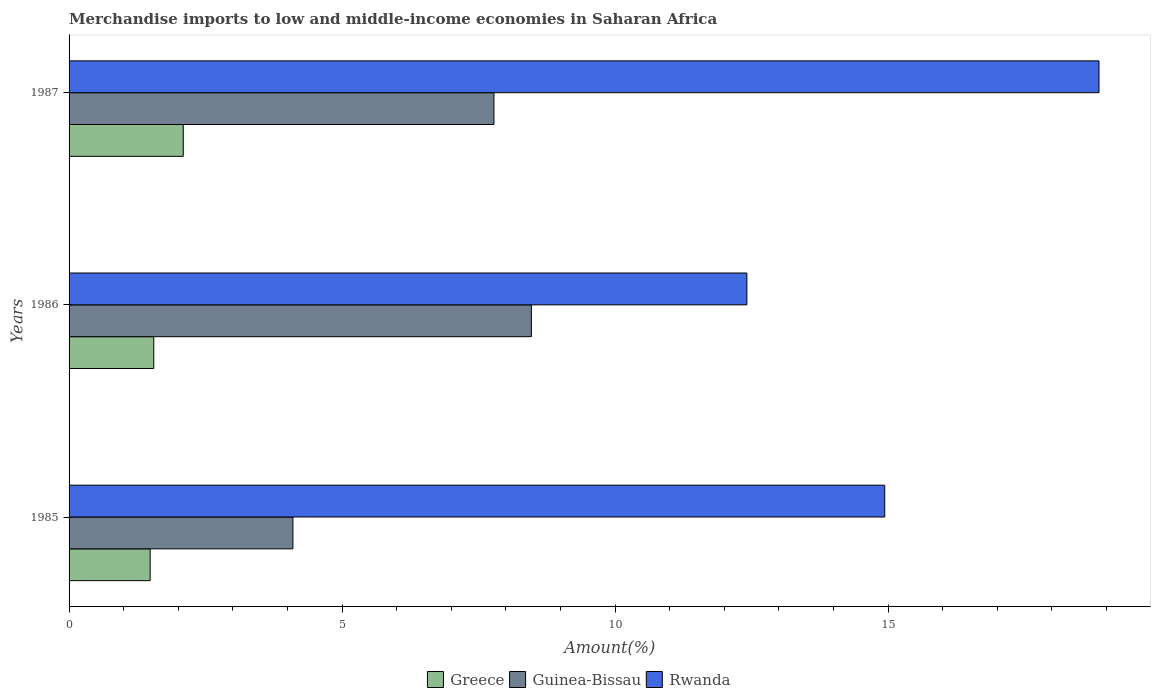Are the number of bars per tick equal to the number of legend labels?
Ensure brevity in your answer.  Yes. What is the label of the 1st group of bars from the top?
Keep it short and to the point. 1987. What is the percentage of amount earned from merchandise imports in Guinea-Bissau in 1987?
Your response must be concise. 7.78. Across all years, what is the maximum percentage of amount earned from merchandise imports in Rwanda?
Keep it short and to the point. 18.86. Across all years, what is the minimum percentage of amount earned from merchandise imports in Rwanda?
Your answer should be compact. 12.41. In which year was the percentage of amount earned from merchandise imports in Guinea-Bissau minimum?
Your answer should be compact. 1985. What is the total percentage of amount earned from merchandise imports in Guinea-Bissau in the graph?
Your answer should be compact. 20.35. What is the difference between the percentage of amount earned from merchandise imports in Rwanda in 1985 and that in 1986?
Make the answer very short. 2.52. What is the difference between the percentage of amount earned from merchandise imports in Greece in 1987 and the percentage of amount earned from merchandise imports in Guinea-Bissau in 1985?
Your answer should be compact. -2.01. What is the average percentage of amount earned from merchandise imports in Guinea-Bissau per year?
Your response must be concise. 6.78. In the year 1985, what is the difference between the percentage of amount earned from merchandise imports in Guinea-Bissau and percentage of amount earned from merchandise imports in Greece?
Ensure brevity in your answer.  2.61. In how many years, is the percentage of amount earned from merchandise imports in Rwanda greater than 16 %?
Keep it short and to the point. 1. What is the ratio of the percentage of amount earned from merchandise imports in Rwanda in 1985 to that in 1987?
Your answer should be very brief. 0.79. Is the percentage of amount earned from merchandise imports in Rwanda in 1985 less than that in 1986?
Make the answer very short. No. What is the difference between the highest and the second highest percentage of amount earned from merchandise imports in Greece?
Your answer should be compact. 0.54. What is the difference between the highest and the lowest percentage of amount earned from merchandise imports in Greece?
Provide a short and direct response. 0.61. Is the sum of the percentage of amount earned from merchandise imports in Rwanda in 1986 and 1987 greater than the maximum percentage of amount earned from merchandise imports in Greece across all years?
Provide a succinct answer. Yes. What does the 3rd bar from the top in 1986 represents?
Offer a very short reply. Greece. What does the 2nd bar from the bottom in 1986 represents?
Your response must be concise. Guinea-Bissau. Where does the legend appear in the graph?
Your response must be concise. Bottom center. How many legend labels are there?
Your answer should be compact. 3. How are the legend labels stacked?
Provide a succinct answer. Horizontal. What is the title of the graph?
Ensure brevity in your answer.  Merchandise imports to low and middle-income economies in Saharan Africa. Does "Montenegro" appear as one of the legend labels in the graph?
Your response must be concise. No. What is the label or title of the X-axis?
Provide a short and direct response. Amount(%). What is the label or title of the Y-axis?
Your answer should be very brief. Years. What is the Amount(%) in Greece in 1985?
Your answer should be compact. 1.48. What is the Amount(%) in Guinea-Bissau in 1985?
Make the answer very short. 4.1. What is the Amount(%) of Rwanda in 1985?
Offer a terse response. 14.94. What is the Amount(%) of Greece in 1986?
Provide a succinct answer. 1.55. What is the Amount(%) of Guinea-Bissau in 1986?
Your answer should be very brief. 8.47. What is the Amount(%) in Rwanda in 1986?
Keep it short and to the point. 12.41. What is the Amount(%) of Greece in 1987?
Provide a succinct answer. 2.09. What is the Amount(%) in Guinea-Bissau in 1987?
Offer a terse response. 7.78. What is the Amount(%) of Rwanda in 1987?
Offer a very short reply. 18.86. Across all years, what is the maximum Amount(%) of Greece?
Provide a short and direct response. 2.09. Across all years, what is the maximum Amount(%) of Guinea-Bissau?
Offer a very short reply. 8.47. Across all years, what is the maximum Amount(%) of Rwanda?
Offer a very short reply. 18.86. Across all years, what is the minimum Amount(%) of Greece?
Provide a short and direct response. 1.48. Across all years, what is the minimum Amount(%) of Guinea-Bissau?
Offer a terse response. 4.1. Across all years, what is the minimum Amount(%) of Rwanda?
Keep it short and to the point. 12.41. What is the total Amount(%) of Greece in the graph?
Provide a short and direct response. 5.13. What is the total Amount(%) of Guinea-Bissau in the graph?
Keep it short and to the point. 20.35. What is the total Amount(%) in Rwanda in the graph?
Your response must be concise. 46.22. What is the difference between the Amount(%) in Greece in 1985 and that in 1986?
Your answer should be very brief. -0.07. What is the difference between the Amount(%) of Guinea-Bissau in 1985 and that in 1986?
Keep it short and to the point. -4.37. What is the difference between the Amount(%) in Rwanda in 1985 and that in 1986?
Your answer should be compact. 2.52. What is the difference between the Amount(%) of Greece in 1985 and that in 1987?
Ensure brevity in your answer.  -0.61. What is the difference between the Amount(%) of Guinea-Bissau in 1985 and that in 1987?
Keep it short and to the point. -3.68. What is the difference between the Amount(%) in Rwanda in 1985 and that in 1987?
Keep it short and to the point. -3.92. What is the difference between the Amount(%) in Greece in 1986 and that in 1987?
Your answer should be compact. -0.54. What is the difference between the Amount(%) of Guinea-Bissau in 1986 and that in 1987?
Make the answer very short. 0.69. What is the difference between the Amount(%) in Rwanda in 1986 and that in 1987?
Your response must be concise. -6.45. What is the difference between the Amount(%) in Greece in 1985 and the Amount(%) in Guinea-Bissau in 1986?
Your answer should be compact. -6.98. What is the difference between the Amount(%) in Greece in 1985 and the Amount(%) in Rwanda in 1986?
Provide a short and direct response. -10.93. What is the difference between the Amount(%) in Guinea-Bissau in 1985 and the Amount(%) in Rwanda in 1986?
Give a very brief answer. -8.31. What is the difference between the Amount(%) in Greece in 1985 and the Amount(%) in Guinea-Bissau in 1987?
Offer a very short reply. -6.3. What is the difference between the Amount(%) in Greece in 1985 and the Amount(%) in Rwanda in 1987?
Keep it short and to the point. -17.38. What is the difference between the Amount(%) of Guinea-Bissau in 1985 and the Amount(%) of Rwanda in 1987?
Keep it short and to the point. -14.76. What is the difference between the Amount(%) in Greece in 1986 and the Amount(%) in Guinea-Bissau in 1987?
Your answer should be compact. -6.23. What is the difference between the Amount(%) of Greece in 1986 and the Amount(%) of Rwanda in 1987?
Your answer should be very brief. -17.31. What is the difference between the Amount(%) in Guinea-Bissau in 1986 and the Amount(%) in Rwanda in 1987?
Offer a terse response. -10.4. What is the average Amount(%) of Greece per year?
Ensure brevity in your answer.  1.71. What is the average Amount(%) of Guinea-Bissau per year?
Your response must be concise. 6.78. What is the average Amount(%) in Rwanda per year?
Keep it short and to the point. 15.41. In the year 1985, what is the difference between the Amount(%) in Greece and Amount(%) in Guinea-Bissau?
Ensure brevity in your answer.  -2.61. In the year 1985, what is the difference between the Amount(%) of Greece and Amount(%) of Rwanda?
Your answer should be very brief. -13.45. In the year 1985, what is the difference between the Amount(%) in Guinea-Bissau and Amount(%) in Rwanda?
Give a very brief answer. -10.84. In the year 1986, what is the difference between the Amount(%) in Greece and Amount(%) in Guinea-Bissau?
Provide a succinct answer. -6.92. In the year 1986, what is the difference between the Amount(%) of Greece and Amount(%) of Rwanda?
Keep it short and to the point. -10.86. In the year 1986, what is the difference between the Amount(%) of Guinea-Bissau and Amount(%) of Rwanda?
Make the answer very short. -3.95. In the year 1987, what is the difference between the Amount(%) of Greece and Amount(%) of Guinea-Bissau?
Make the answer very short. -5.69. In the year 1987, what is the difference between the Amount(%) of Greece and Amount(%) of Rwanda?
Your response must be concise. -16.77. In the year 1987, what is the difference between the Amount(%) in Guinea-Bissau and Amount(%) in Rwanda?
Make the answer very short. -11.08. What is the ratio of the Amount(%) of Greece in 1985 to that in 1986?
Your answer should be very brief. 0.96. What is the ratio of the Amount(%) in Guinea-Bissau in 1985 to that in 1986?
Provide a short and direct response. 0.48. What is the ratio of the Amount(%) of Rwanda in 1985 to that in 1986?
Make the answer very short. 1.2. What is the ratio of the Amount(%) of Greece in 1985 to that in 1987?
Offer a terse response. 0.71. What is the ratio of the Amount(%) in Guinea-Bissau in 1985 to that in 1987?
Provide a short and direct response. 0.53. What is the ratio of the Amount(%) of Rwanda in 1985 to that in 1987?
Provide a short and direct response. 0.79. What is the ratio of the Amount(%) in Greece in 1986 to that in 1987?
Your answer should be compact. 0.74. What is the ratio of the Amount(%) of Guinea-Bissau in 1986 to that in 1987?
Offer a very short reply. 1.09. What is the ratio of the Amount(%) in Rwanda in 1986 to that in 1987?
Your response must be concise. 0.66. What is the difference between the highest and the second highest Amount(%) of Greece?
Provide a succinct answer. 0.54. What is the difference between the highest and the second highest Amount(%) of Guinea-Bissau?
Ensure brevity in your answer.  0.69. What is the difference between the highest and the second highest Amount(%) of Rwanda?
Give a very brief answer. 3.92. What is the difference between the highest and the lowest Amount(%) of Greece?
Offer a terse response. 0.61. What is the difference between the highest and the lowest Amount(%) in Guinea-Bissau?
Your answer should be compact. 4.37. What is the difference between the highest and the lowest Amount(%) of Rwanda?
Your answer should be compact. 6.45. 